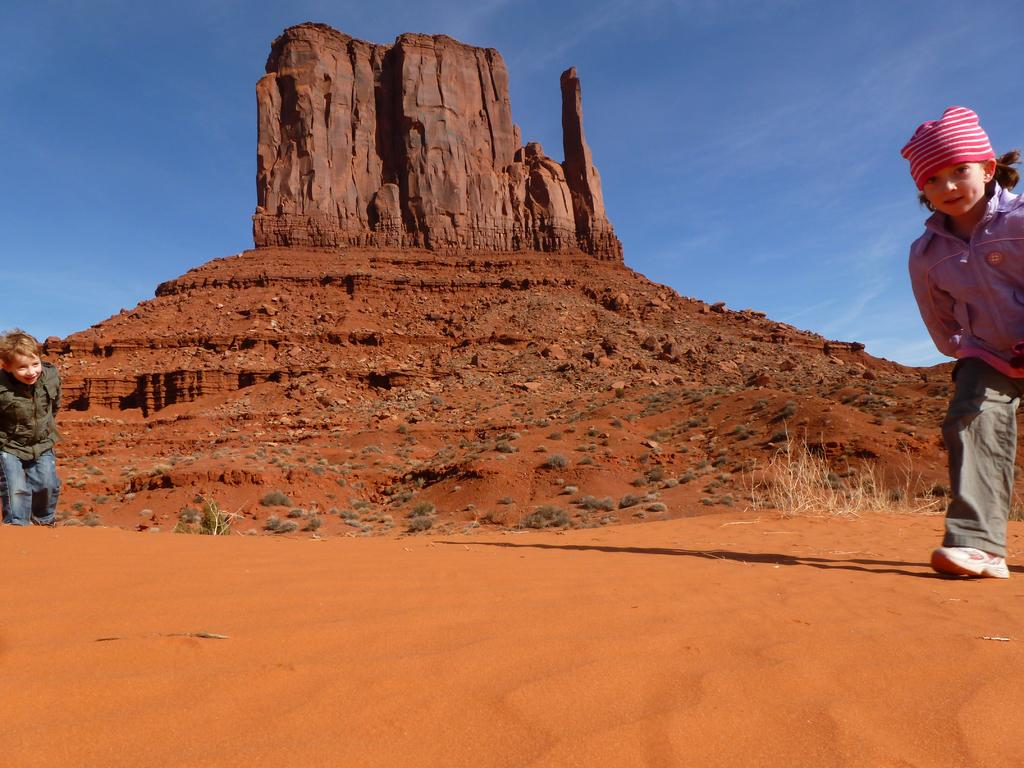How many children are present in the image? There are two children in the image. What are the children doing in the image? The children are running. What type of terrain is at the bottom of the image? There is sand at the bottom of the image. What can be seen in the background of the image? There is a mountain and the sky visible in the background of the image. Where is the sofa located in the image? There is no sofa present in the image. What type of soup is being served in the image? There is no soup present in the image. 